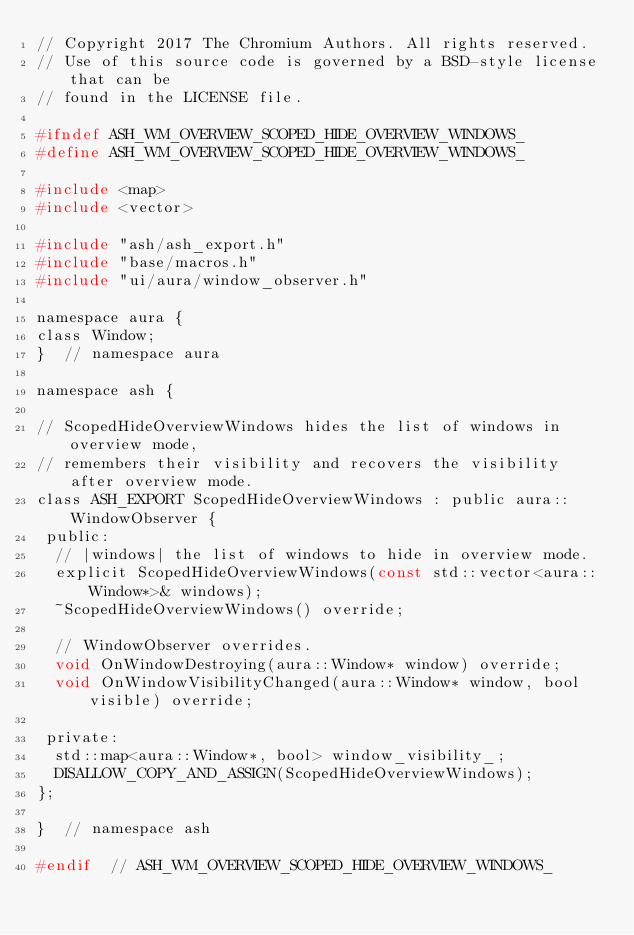<code> <loc_0><loc_0><loc_500><loc_500><_C_>// Copyright 2017 The Chromium Authors. All rights reserved.
// Use of this source code is governed by a BSD-style license that can be
// found in the LICENSE file.

#ifndef ASH_WM_OVERVIEW_SCOPED_HIDE_OVERVIEW_WINDOWS_
#define ASH_WM_OVERVIEW_SCOPED_HIDE_OVERVIEW_WINDOWS_

#include <map>
#include <vector>

#include "ash/ash_export.h"
#include "base/macros.h"
#include "ui/aura/window_observer.h"

namespace aura {
class Window;
}  // namespace aura

namespace ash {

// ScopedHideOverviewWindows hides the list of windows in overview mode,
// remembers their visibility and recovers the visibility after overview mode.
class ASH_EXPORT ScopedHideOverviewWindows : public aura::WindowObserver {
 public:
  // |windows| the list of windows to hide in overview mode.
  explicit ScopedHideOverviewWindows(const std::vector<aura::Window*>& windows);
  ~ScopedHideOverviewWindows() override;

  // WindowObserver overrides.
  void OnWindowDestroying(aura::Window* window) override;
  void OnWindowVisibilityChanged(aura::Window* window, bool visible) override;

 private:
  std::map<aura::Window*, bool> window_visibility_;
  DISALLOW_COPY_AND_ASSIGN(ScopedHideOverviewWindows);
};

}  // namespace ash

#endif  // ASH_WM_OVERVIEW_SCOPED_HIDE_OVERVIEW_WINDOWS_</code> 